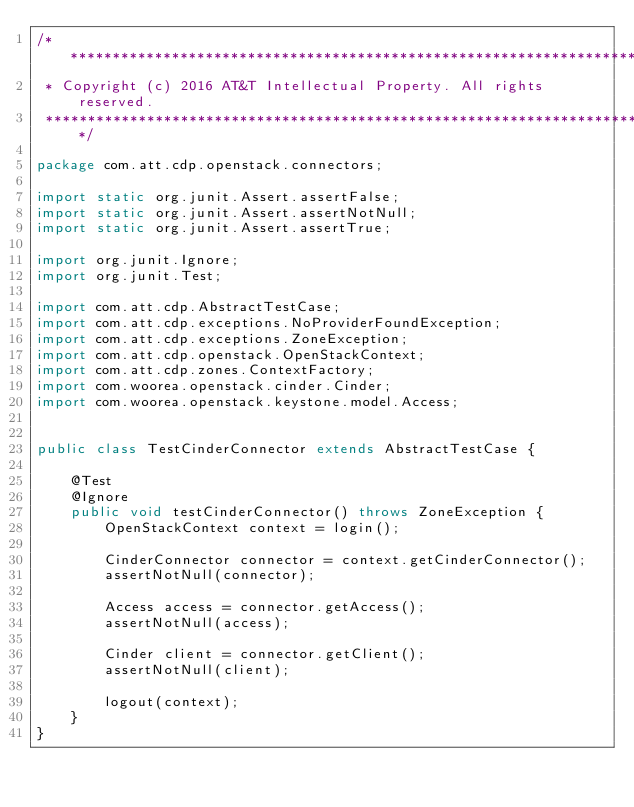<code> <loc_0><loc_0><loc_500><loc_500><_Java_>/*******************************************************************************
 * Copyright (c) 2016 AT&T Intellectual Property. All rights reserved.
 *******************************************************************************/

package com.att.cdp.openstack.connectors;

import static org.junit.Assert.assertFalse;
import static org.junit.Assert.assertNotNull;
import static org.junit.Assert.assertTrue;

import org.junit.Ignore;
import org.junit.Test;

import com.att.cdp.AbstractTestCase;
import com.att.cdp.exceptions.NoProviderFoundException;
import com.att.cdp.exceptions.ZoneException;
import com.att.cdp.openstack.OpenStackContext;
import com.att.cdp.zones.ContextFactory;
import com.woorea.openstack.cinder.Cinder;
import com.woorea.openstack.keystone.model.Access;


public class TestCinderConnector extends AbstractTestCase {

    @Test
    @Ignore
    public void testCinderConnector() throws ZoneException {
        OpenStackContext context = login();

        CinderConnector connector = context.getCinderConnector();
        assertNotNull(connector);

        Access access = connector.getAccess();
        assertNotNull(access);

        Cinder client = connector.getClient();
        assertNotNull(client);

        logout(context);
    }
}
</code> 